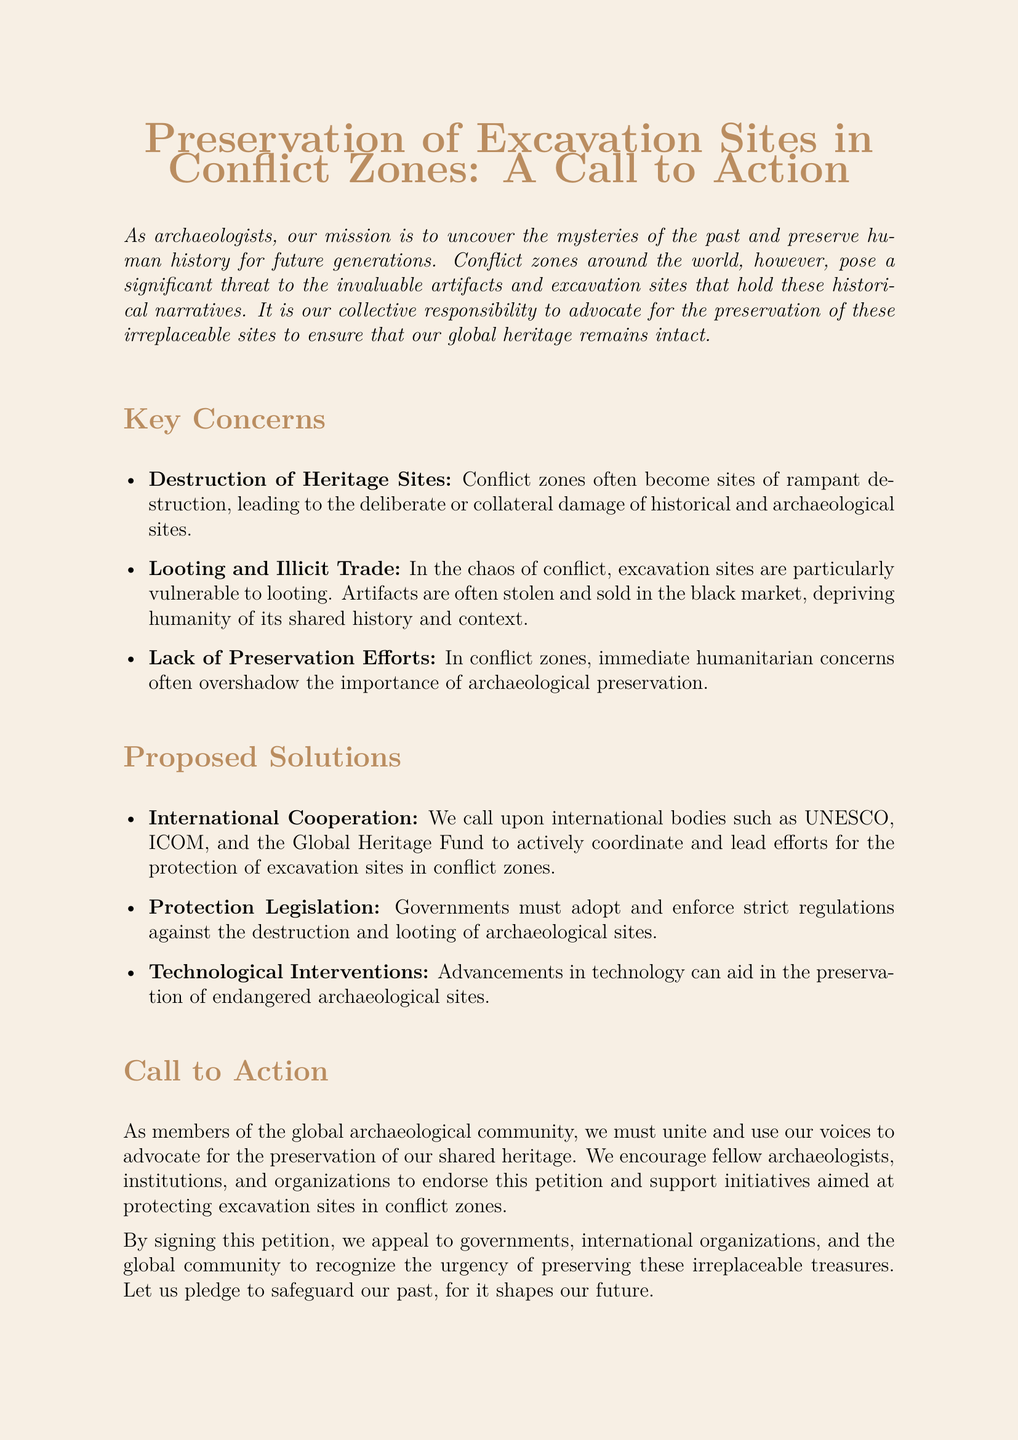what is the title of the document? The title is prominently displayed at the top of the document, clearly indicating its subject matter.
Answer: Preservation of Excavation Sites in Conflict Zones: A Call to Action what are three key concerns listed in the document? The document outlines important issues regarding the preservation of archaeological sites, listing three main concerns.
Answer: Destruction of Heritage Sites, Looting and Illicit Trade, Lack of Preservation Efforts who is called upon for international cooperation? The document specifies organizations that should coordinate efforts for the protection of excavation sites.
Answer: UNESCO, ICOM, and the Global Heritage Fund what significant action does the petition urge from governments? The petition outlines necessary steps that governments should take to secure archaeological sites and prevent damage.
Answer: Adopt and enforce strict regulations how does the document suggest using technology? The document mentions how advancements in technology can contribute to the preservation of archaeological sites.
Answer: Aid in the preservation of endangered archaeological sites what is the purpose of signing the petition? The document explains the aim behind signing the petition, emphasizing the urgency of the cause.
Answer: To recognize the urgency of preserving these irreplaceable treasures how many columns are used in the signature section? The structure of the document divides the signature section into multiple parts for clarity and organization.
Answer: Three what type of document is this? The nature and function of the document can be identified based on its content and structure.
Answer: Petition 